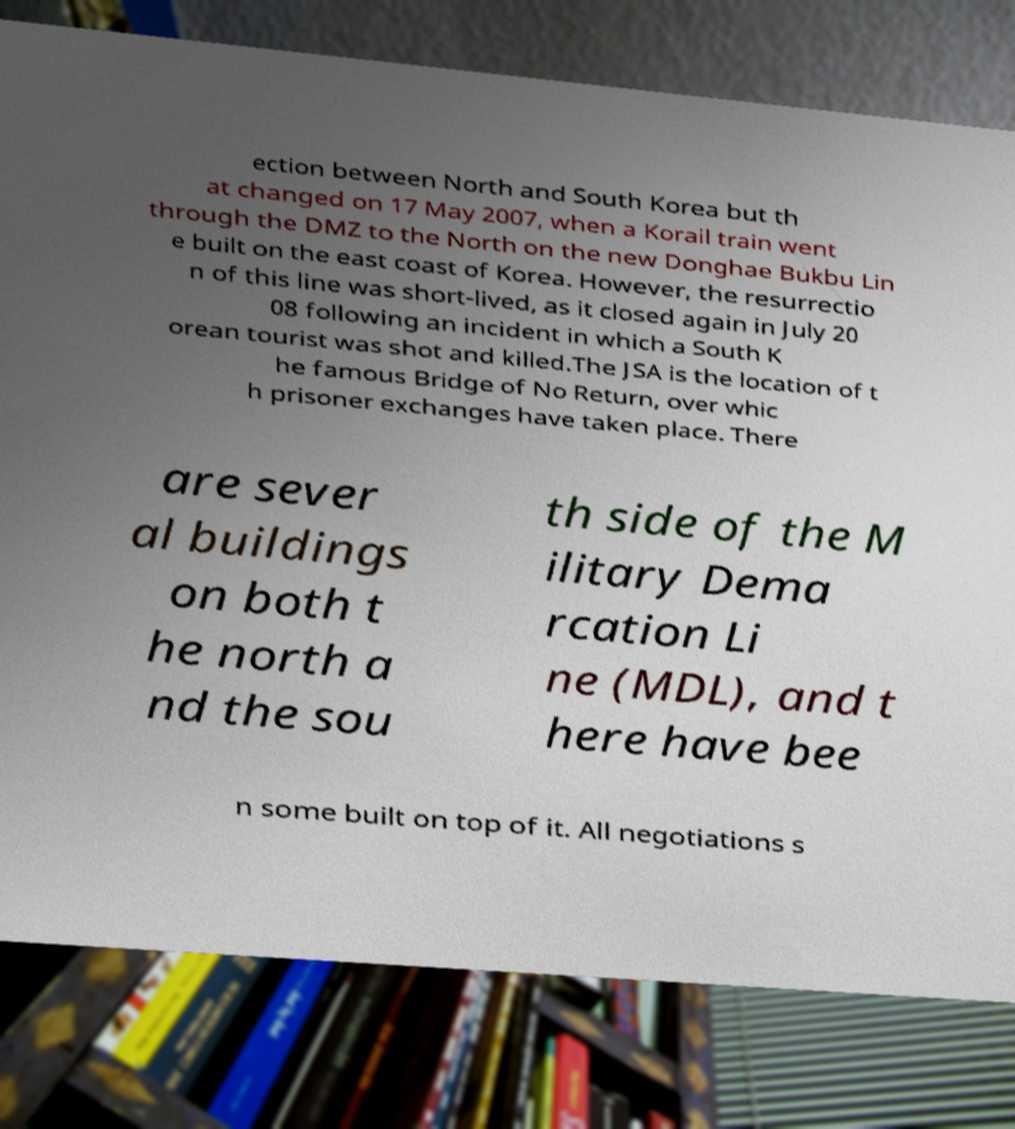Please identify and transcribe the text found in this image. ection between North and South Korea but th at changed on 17 May 2007, when a Korail train went through the DMZ to the North on the new Donghae Bukbu Lin e built on the east coast of Korea. However, the resurrectio n of this line was short-lived, as it closed again in July 20 08 following an incident in which a South K orean tourist was shot and killed.The JSA is the location of t he famous Bridge of No Return, over whic h prisoner exchanges have taken place. There are sever al buildings on both t he north a nd the sou th side of the M ilitary Dema rcation Li ne (MDL), and t here have bee n some built on top of it. All negotiations s 